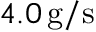Convert formula to latex. <formula><loc_0><loc_0><loc_500><loc_500>4 . 0 \, g / s</formula> 